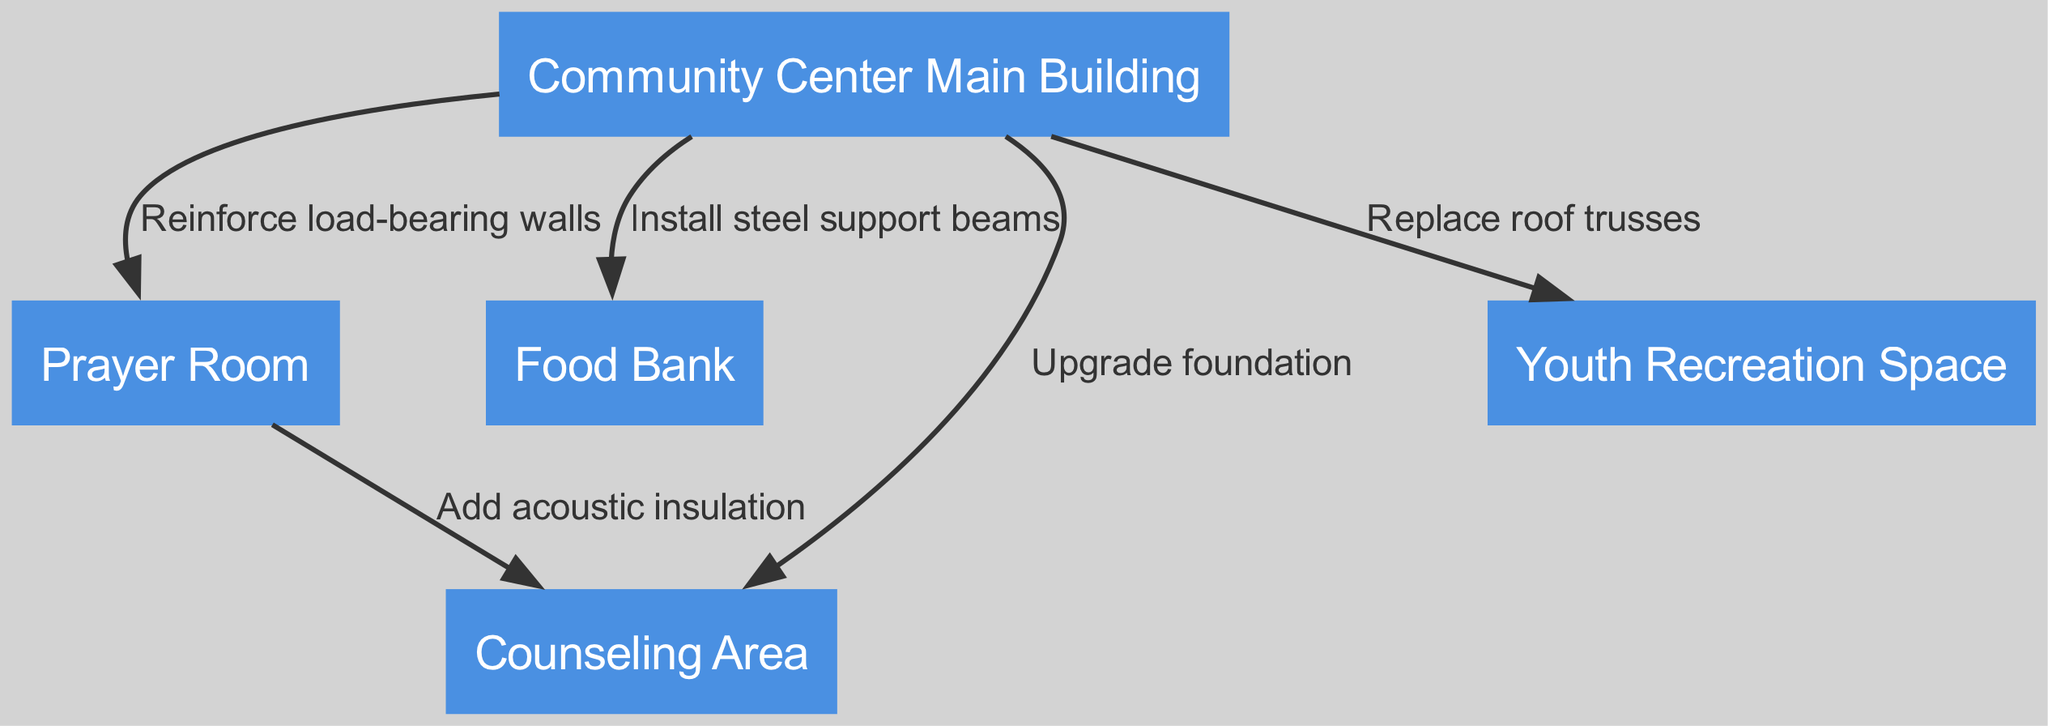What is the total number of nodes in the diagram? The diagram contains five nodes, each representing a different area of the community center: Main Building, Prayer Room, Food Bank, Counseling Area, and Youth Recreation Space.
Answer: 5 What is the reinforcement type for the edge between the Community Center Main Building and the Prayer Room? The label on the edge connecting these two nodes indicates that the reinforcement type is "Reinforce load-bearing walls."
Answer: Reinforce load-bearing walls Which area involves installing steel support beams? The diagram shows that the Food Bank is connected to the Community Center Main Building with an edge labeled "Install steel support beams," indicating this is the area involved.
Answer: Food Bank How many edges are displayed in the diagram? The diagram lists a total of five edges representing the various structural reinforcements and relationships between different nodes, or areas, within the community center.
Answer: 5 What kind of insulation is added to the edge between the Prayer Room and Counseling Area? On the edge connecting the Prayer Room to the Counseling Area, the label specifies "Add acoustic insulation" indicating the type of reinforcement.
Answer: Add acoustic insulation Which structural reinforcement involves updating the foundation? The edge from the Community Center Main Building to the Counseling Area indicates "Upgrade foundation," thus identifying it as the area involved in this structural reinforcement activity.
Answer: Upgrade foundation What type of trusses are being replaced? The connection from the Community Center Main Building to the Youth Recreation Space indicates the action is to "Replace roof trusses," thus specifying the type being replaced.
Answer: Roof trusses Which node is directly connected to both the Prayer Room and the Youth Recreation Space? The Community Center Main Building is the only node that has edges leading to both the Prayer Room and the Youth Recreation Space in the diagram, connecting them directly.
Answer: Community Center Main Building What structural changes are suggested for the area linked to both the Food Bank and the Counseling Area? The diagram indicates that the Food Bank is connected to the Community Center Main with a reinforcement labeled "Install steel support beams," while the Counseling Area is associated with "Upgrade foundation." Thus, both areas involve different types of structural changes related to building stability and support.
Answer: Install steel support beams; Upgrade foundation 